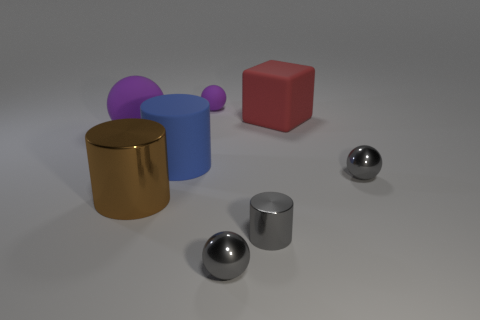Add 2 gray matte balls. How many objects exist? 10 Subtract all cubes. How many objects are left? 7 Add 4 rubber objects. How many rubber objects exist? 8 Subtract 0 yellow cylinders. How many objects are left? 8 Subtract all large rubber spheres. Subtract all small yellow matte blocks. How many objects are left? 7 Add 7 blue matte things. How many blue matte things are left? 8 